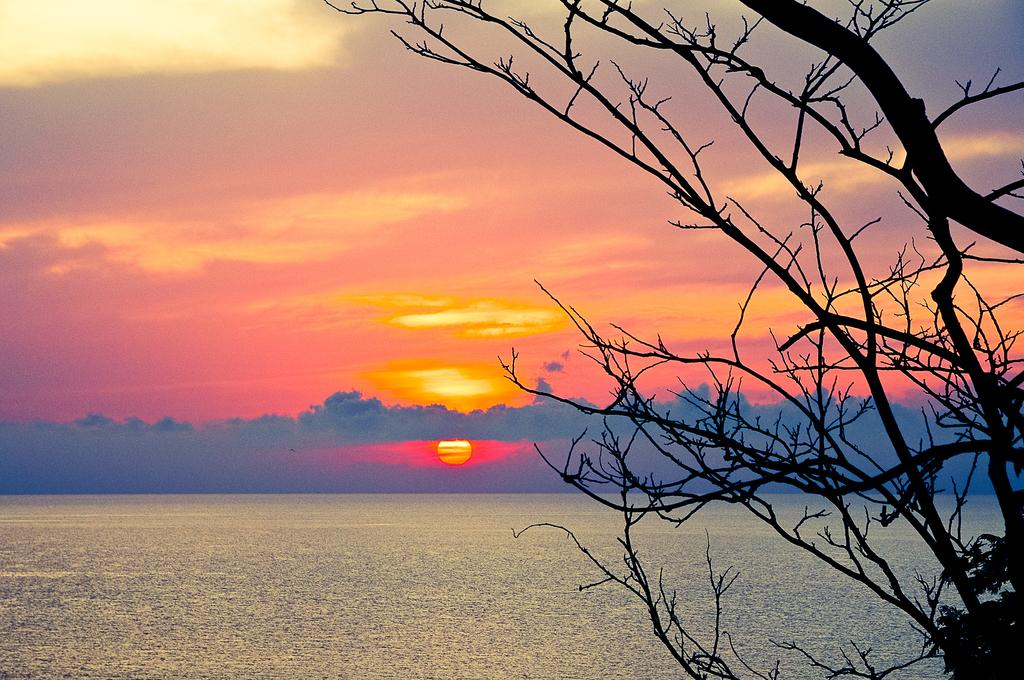What is located on the right side of the image? There is a tree without leaves in the foreground of the image. What can be seen in the background of the image? Water and the sky are visible in the background of the image. Is the sun visible in the image? Yes, the sun is observable in the sky. What is the income of the tree in the image? There is no income associated with the tree in the image, as trees do not have incomes. 